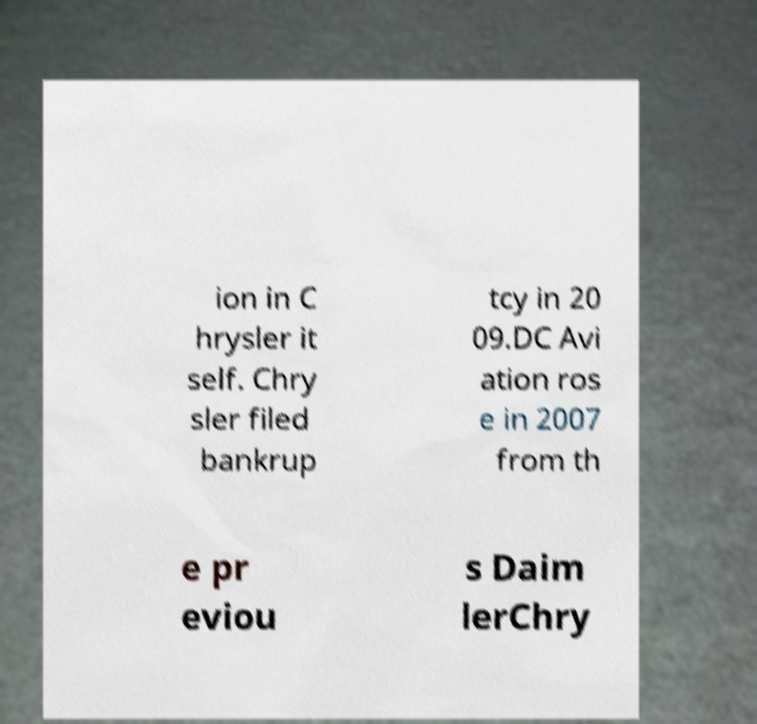There's text embedded in this image that I need extracted. Can you transcribe it verbatim? ion in C hrysler it self. Chry sler filed bankrup tcy in 20 09.DC Avi ation ros e in 2007 from th e pr eviou s Daim lerChry 